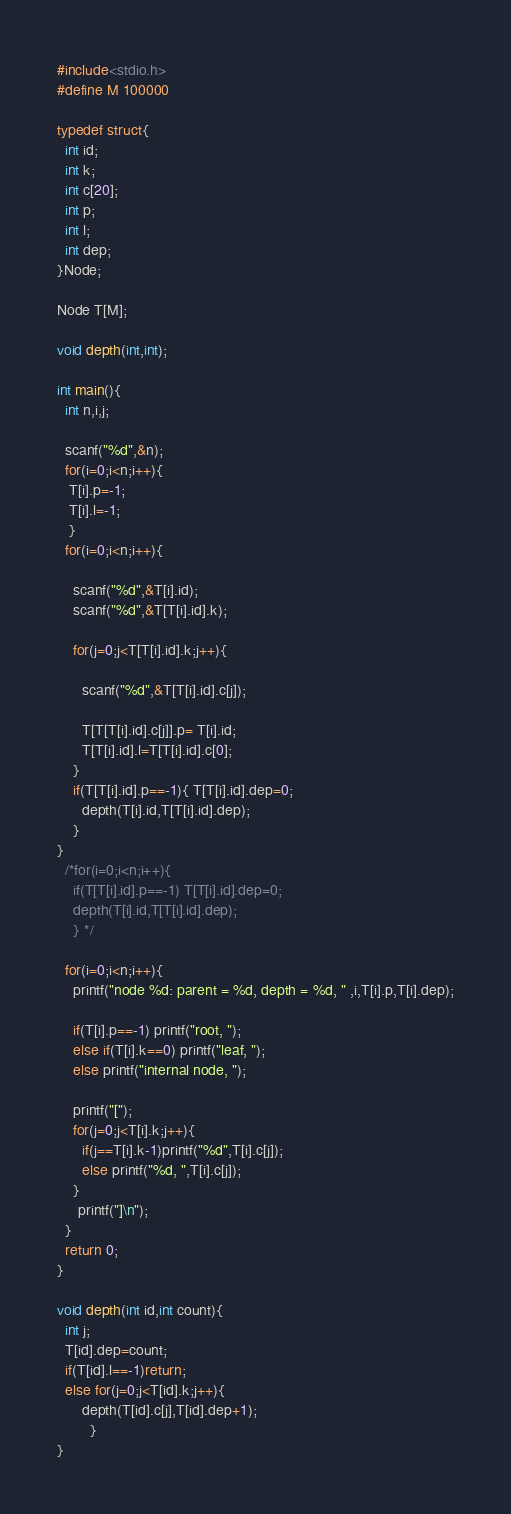<code> <loc_0><loc_0><loc_500><loc_500><_C_>#include<stdio.h>
#define M 100000

typedef struct{
  int id;
  int k;
  int c[20];
  int p;
  int l;
  int dep;
}Node;

Node T[M];

void depth(int,int);

int main(){
  int n,i,j;
  
  scanf("%d",&n);
  for(i=0;i<n;i++){
   T[i].p=-1;
   T[i].l=-1;
   }
  for(i=0;i<n;i++){
   
    scanf("%d",&T[i].id);
    scanf("%d",&T[T[i].id].k);

    for(j=0;j<T[T[i].id].k;j++){

      scanf("%d",&T[T[i].id].c[j]);

      T[T[T[i].id].c[j]].p= T[i].id;
      T[T[i].id].l=T[T[i].id].c[0];
    }
    if(T[T[i].id].p==-1){ T[T[i].id].dep=0;
      depth(T[i].id,T[T[i].id].dep);
    }
}
  /*for(i=0;i<n;i++){
    if(T[T[i].id].p==-1) T[T[i].id].dep=0;
    depth(T[i].id,T[T[i].id].dep);
    } */

  for(i=0;i<n;i++){
    printf("node %d: parent = %d, depth = %d, " ,i,T[i].p,T[i].dep);
   
    if(T[i].p==-1) printf("root, ");
    else if(T[i].k==0) printf("leaf, ");
    else printf("internal node, ");
  
    printf("[");
    for(j=0;j<T[i].k;j++){
      if(j==T[i].k-1)printf("%d",T[i].c[j]);
      else printf("%d, ",T[i].c[j]);
    }
     printf("]\n");
  }
  return 0;
}

void depth(int id,int count){
  int j;
  T[id].dep=count;
  if(T[id].l==-1)return;
  else for(j=0;j<T[id].k;j++){
      depth(T[id].c[j],T[id].dep+1);
	    }
}</code> 